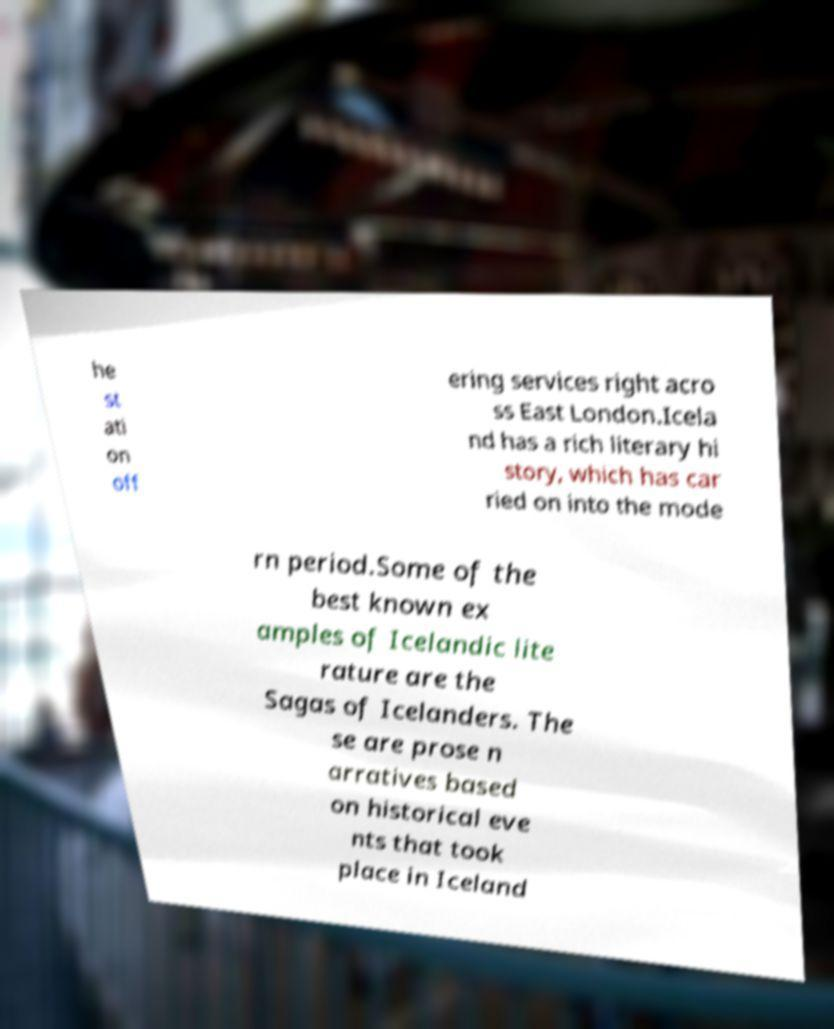Please identify and transcribe the text found in this image. he st ati on off ering services right acro ss East London.Icela nd has a rich literary hi story, which has car ried on into the mode rn period.Some of the best known ex amples of Icelandic lite rature are the Sagas of Icelanders. The se are prose n arratives based on historical eve nts that took place in Iceland 